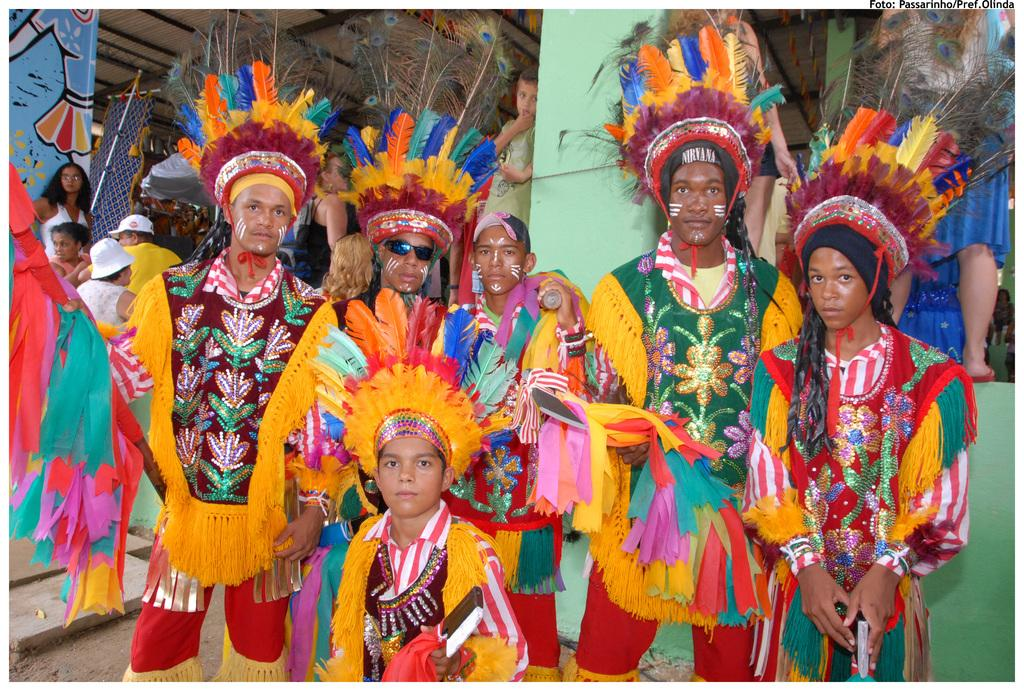Where was the image taken? The image was taken indoors. What can be seen in the foreground of the image? There is a group of people standing in the foreground, and the ground is visible. What is visible in the background of the image? There is a roof visible in the background, and there is another group of people. What type of plastic material can be seen being pushed by the group of people in the image? There is no plastic material being pushed by the group of people in the image. 